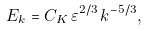<formula> <loc_0><loc_0><loc_500><loc_500>E _ { k } = C _ { K } \, \varepsilon ^ { 2 / 3 } \, k ^ { - 5 / 3 } ,</formula> 